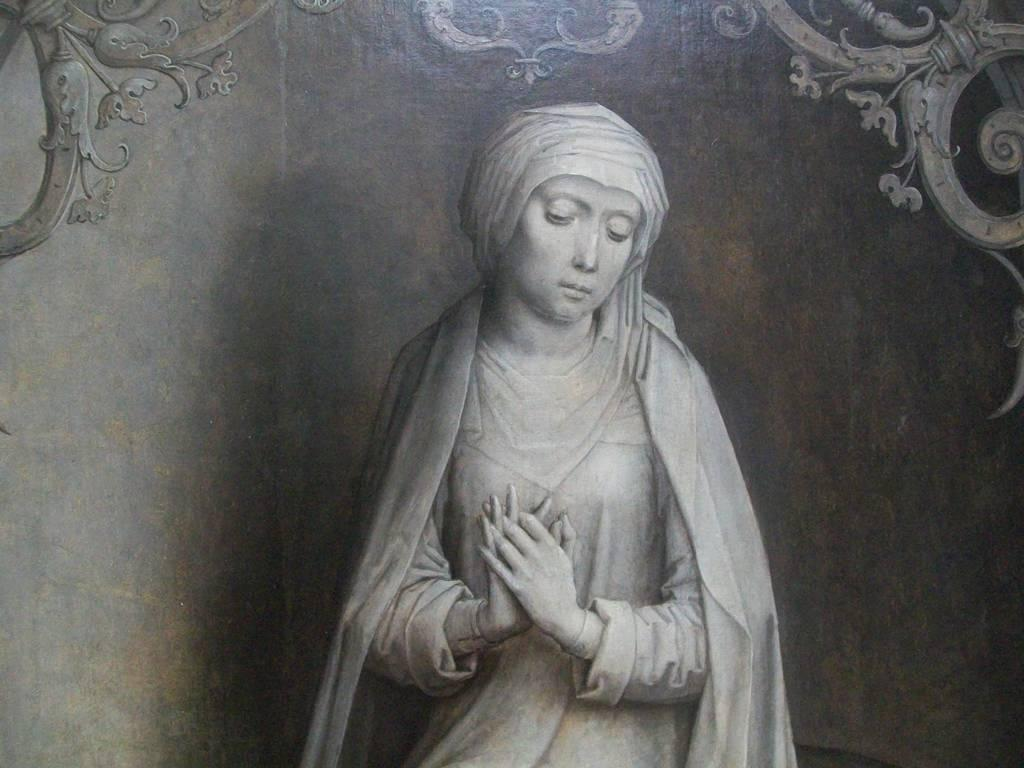What is the main subject of the image? The main subject of the image is a painting of a woman. What can be observed about the painting's design? The painting has some designs. What color scheme is used in the image? The image is black and white in color. Where is the shelf located in the image? There is no shelf present in the image; it features a painting of a woman. What type of plant can be seen growing in the image? There is no plant present in the image; it is a black and white painting of a woman. 